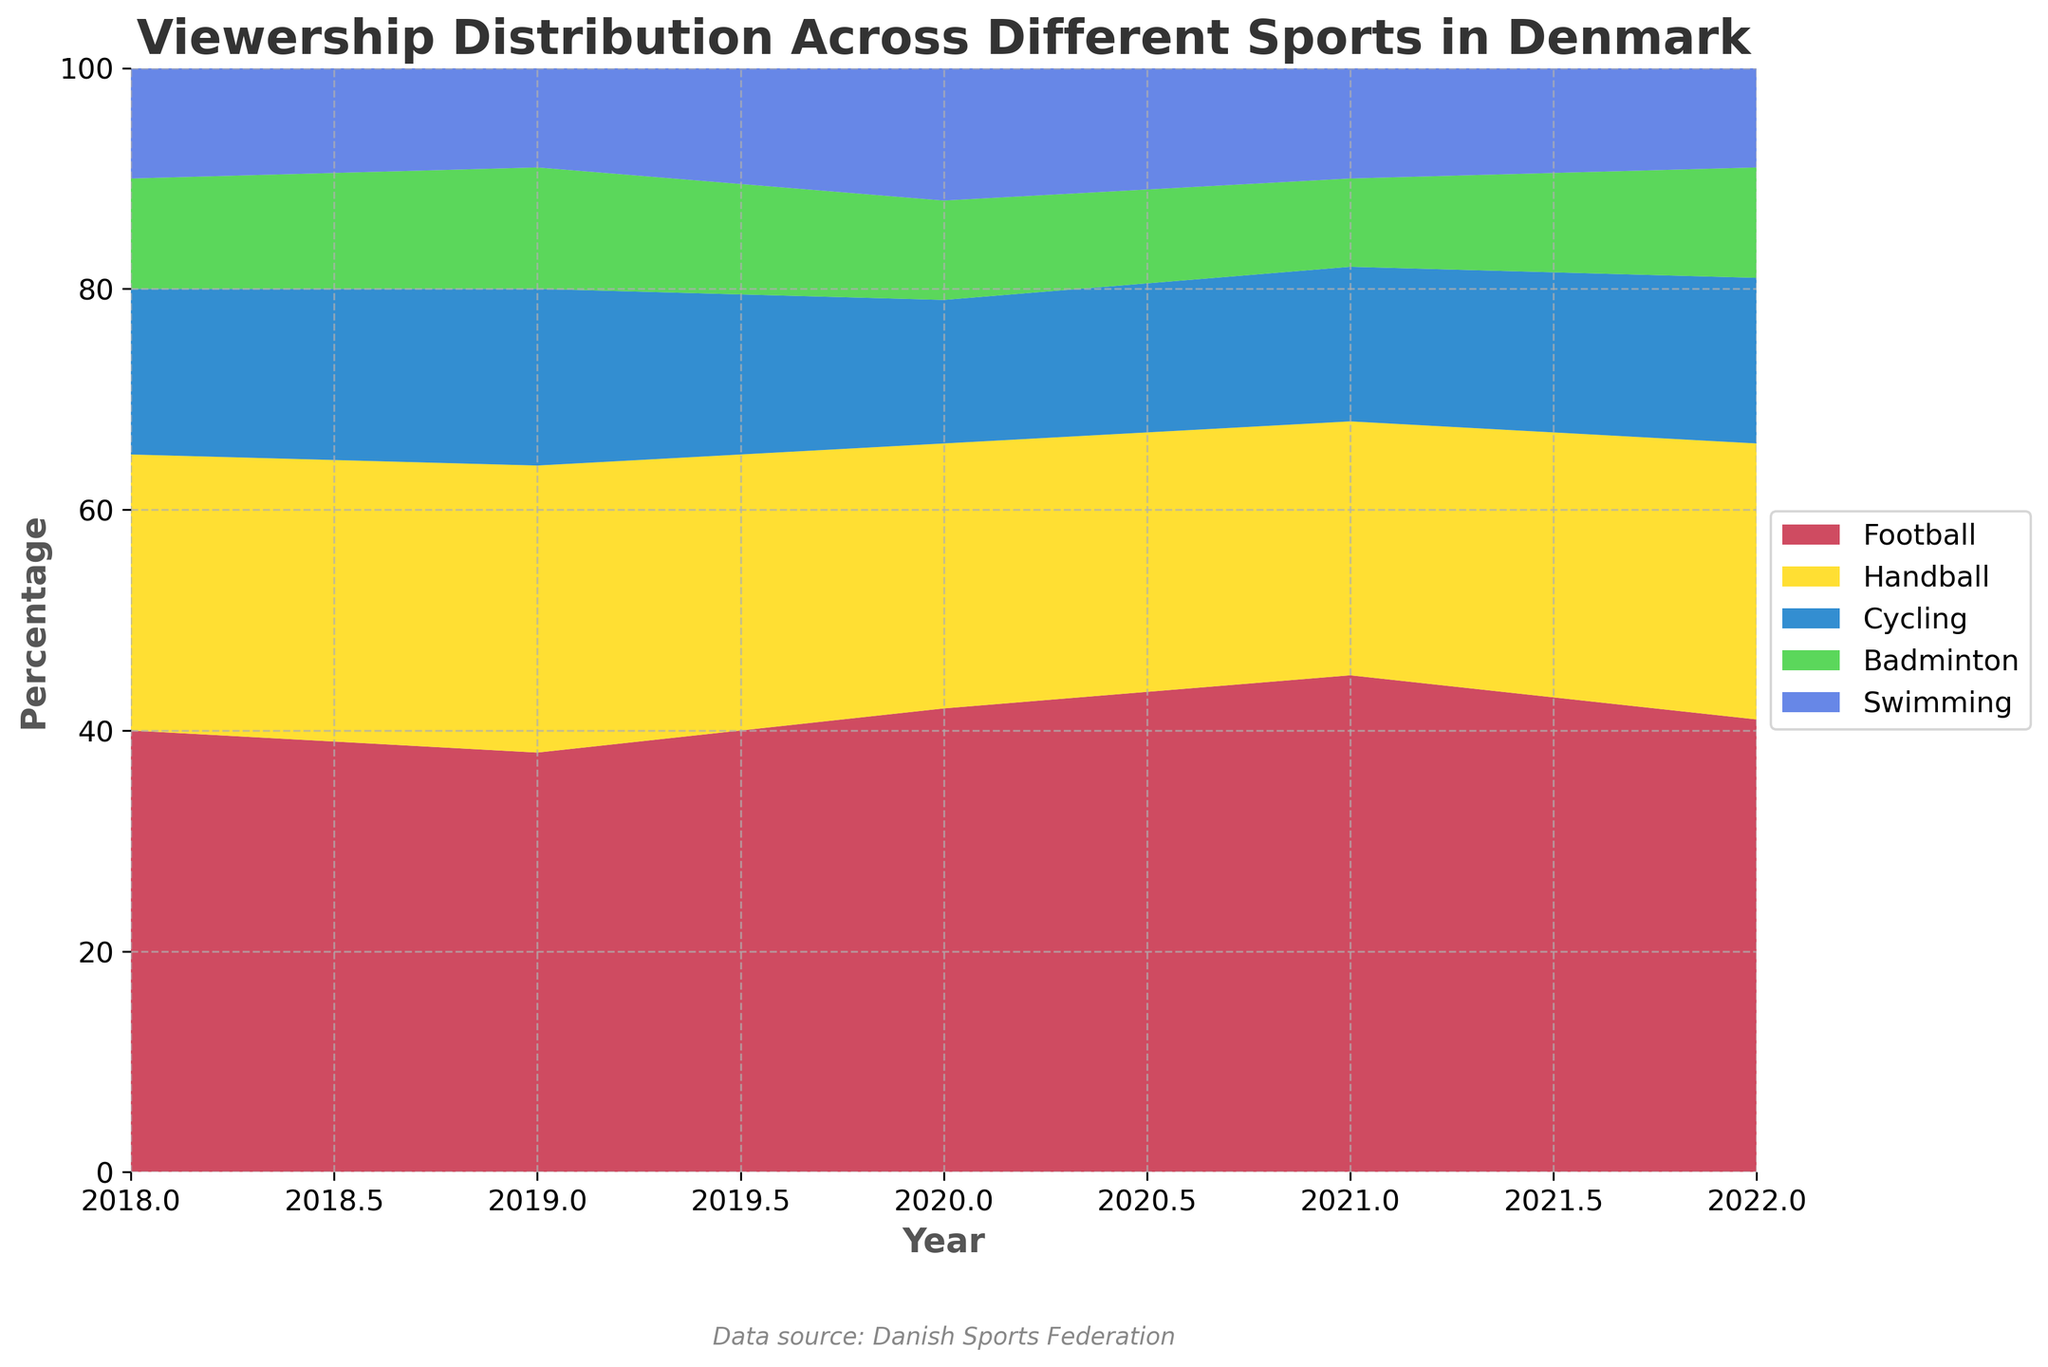What is the title of the figure? The title of the figure is displayed at the top of the chart.
Answer: Viewership Distribution Across Different Sports in Denmark Which years are included in the data? The x-axis of the chart displays the range of years included in the data.
Answer: 2018, 2019, 2020, 2021, 2022 In which year did Football have the highest viewership percentage? By looking at the topmost section of the stacked areas representing Football, it is highest in 2021.
Answer: 2021 Compare the viewership of Handball and Swimming in 2018. Which sport had a higher percentage? By observing the stacked areas, you can see that Handball's area is greater than Swimming's area in 2018.
Answer: Handball Calculate the average viewership percentage of Badminton over the 5 years. Add the percentages for Badminton from 2018 to 2022 and divide by the number of years: (10 + 11 + 9 + 8 + 10) / 5 = 48 / 5 = 9.6
Answer: 9.6% How did the viewership trend for Cycling change from 2018 to 2022? By observing the Cycling area, you can see it decreased from 15% in 2018 to 14% in 2021 and then increased back to 15% in 2022. This shows a slightly fluctuating trend.
Answer: Decreased then increased Which year showed the lowest percentage of Swimming viewership? By comparing the percentages for Swimming across all years, 2019 had the lowest percentage at 9%.
Answer: 2019 Between Handball and Badminton, which sport had a more stable viewership percentage over the years? Handball's percentage ranges between 23% and 26%, whereas Badminton fluctuates between 8% and 11%. Handball shows a more stable trend.
Answer: Handball What is the percentage difference between the highest and lowest viewership years for Football? The highest viewership percentage for Football was 45% in 2021, and the lowest was 38% in 2019. The difference is 45% - 38% = 7%.
Answer: 7% How did the popularity of Football evolve compared to other sports from 2018 to 2022? Observing the chart, Football's percentage increased overall from 40% in 2018 to 41% in 2022, particularly peaking in 2021 with 45%, indicating a growth trend while the other sports show slight fluctuations without a clear upward trend.
Answer: Increased overall 